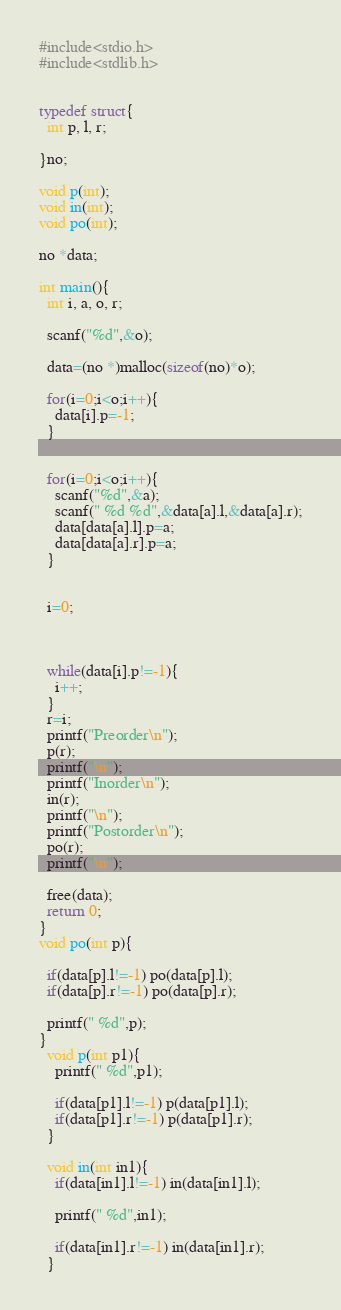<code> <loc_0><loc_0><loc_500><loc_500><_C_>

#include<stdio.h>
#include<stdlib.h>


typedef struct{
  int p, l, r;
  
}no;

void p(int);
void in(int);
void po(int);

no *data;

int main(){
  int i, a, o, r;

  scanf("%d",&o);
  
  data=(no *)malloc(sizeof(no)*o);
  
  for(i=0;i<o;i++){
    data[i].p=-1;
  }

  
  for(i=0;i<o;i++){
    scanf("%d",&a);
    scanf(" %d %d",&data[a].l,&data[a].r);
    data[data[a].l].p=a;
    data[data[a].r].p=a;
  }


  i=0;


  
  while(data[i].p!=-1){
    i++;
  }
  r=i;
  printf("Preorder\n");
  p(r);
  printf("\n");
  printf("Inorder\n");
  in(r);
  printf("\n");
  printf("Postorder\n");
  po(r);
  printf("\n");
  
  free(data);
  return 0;
}
void po(int p){

  if(data[p].l!=-1) po(data[p].l);
  if(data[p].r!=-1) po(data[p].r);

  printf(" %d",p);
}
  void p(int p1){
    printf(" %d",p1);

    if(data[p1].l!=-1) p(data[p1].l);
    if(data[p1].r!=-1) p(data[p1].r);
  }

  void in(int in1){
    if(data[in1].l!=-1) in(data[in1].l);

    printf(" %d",in1);

    if(data[in1].r!=-1) in(data[in1].r);
  }


</code> 